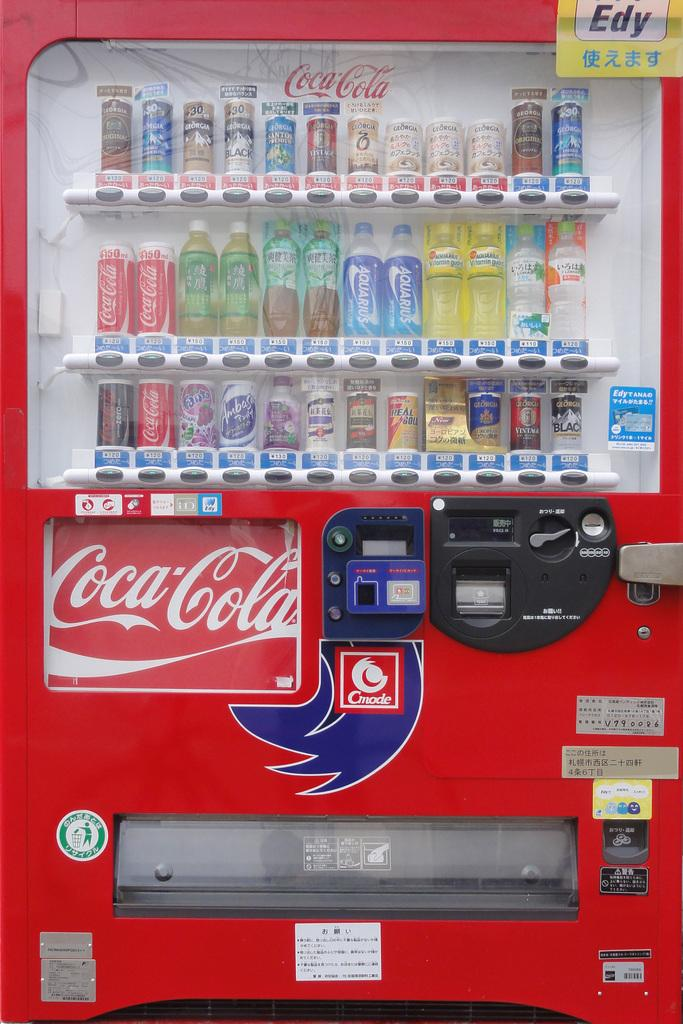<image>
Share a concise interpretation of the image provided. A Coca-Cola vending machine that accepts credit cards. 